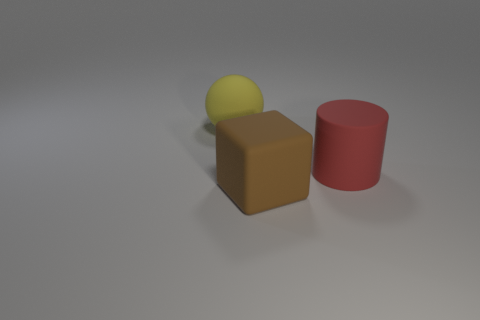Is the size of the rubber block the same as the red cylinder? From a visual comparison, the rubber block and the red cylinder do not appear to be the same size. The rubber block seems to have dimensions that suggest it is slightly smaller in length than the height of the red cylinder. 